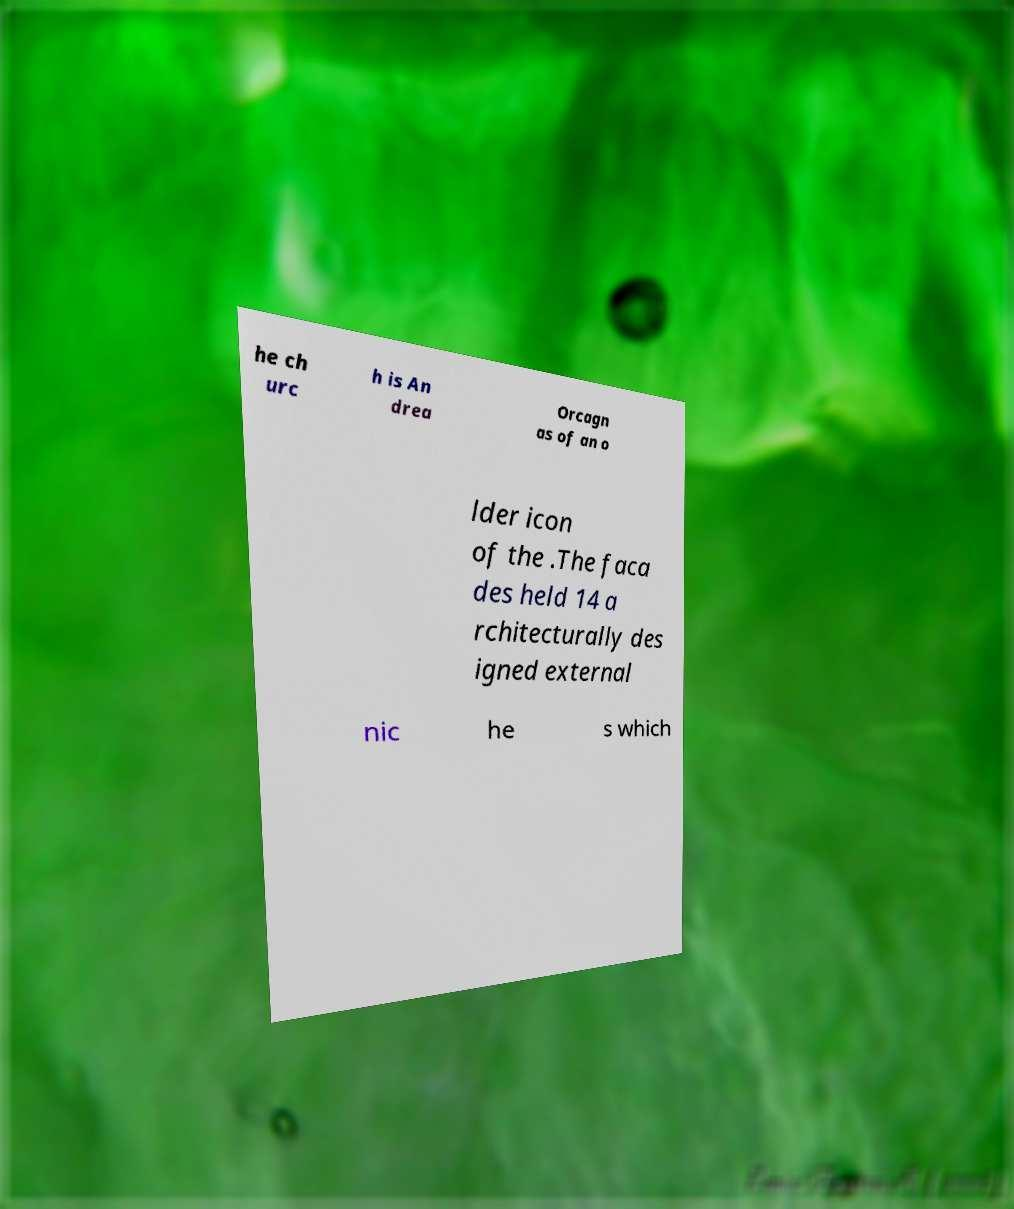Please read and relay the text visible in this image. What does it say? he ch urc h is An drea Orcagn as of an o lder icon of the .The faca des held 14 a rchitecturally des igned external nic he s which 